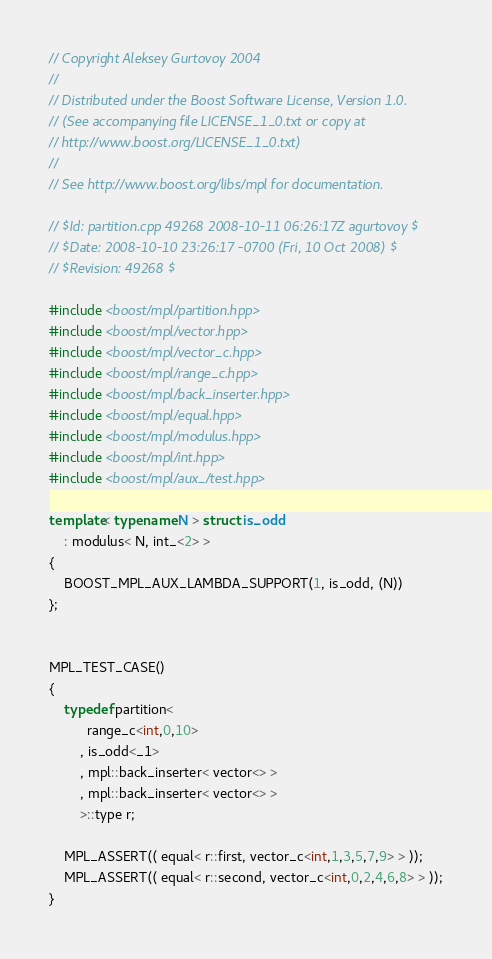Convert code to text. <code><loc_0><loc_0><loc_500><loc_500><_C++_>
// Copyright Aleksey Gurtovoy 2004
//
// Distributed under the Boost Software License, Version 1.0. 
// (See accompanying file LICENSE_1_0.txt or copy at 
// http://www.boost.org/LICENSE_1_0.txt)
//
// See http://www.boost.org/libs/mpl for documentation.

// $Id: partition.cpp 49268 2008-10-11 06:26:17Z agurtovoy $
// $Date: 2008-10-10 23:26:17 -0700 (Fri, 10 Oct 2008) $
// $Revision: 49268 $

#include <boost/mpl/partition.hpp>
#include <boost/mpl/vector.hpp>
#include <boost/mpl/vector_c.hpp>
#include <boost/mpl/range_c.hpp>
#include <boost/mpl/back_inserter.hpp>
#include <boost/mpl/equal.hpp>
#include <boost/mpl/modulus.hpp>
#include <boost/mpl/int.hpp>
#include <boost/mpl/aux_/test.hpp>

template< typename N > struct is_odd
    : modulus< N, int_<2> > 
{
    BOOST_MPL_AUX_LAMBDA_SUPPORT(1, is_odd, (N))
};


MPL_TEST_CASE()
{
    typedef partition<
          range_c<int,0,10> 
        , is_odd<_1>
        , mpl::back_inserter< vector<> >
        , mpl::back_inserter< vector<> >
        >::type r;

    MPL_ASSERT(( equal< r::first, vector_c<int,1,3,5,7,9> > ));
    MPL_ASSERT(( equal< r::second, vector_c<int,0,2,4,6,8> > ));
}
</code> 